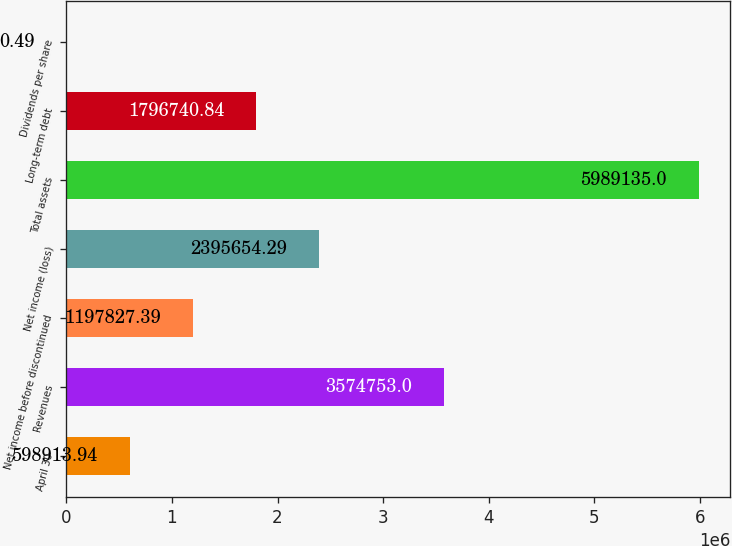Convert chart. <chart><loc_0><loc_0><loc_500><loc_500><bar_chart><fcel>April 30<fcel>Revenues<fcel>Net income before discontinued<fcel>Net income (loss)<fcel>Total assets<fcel>Long-term debt<fcel>Dividends per share<nl><fcel>598914<fcel>3.57475e+06<fcel>1.19783e+06<fcel>2.39565e+06<fcel>5.98914e+06<fcel>1.79674e+06<fcel>0.49<nl></chart> 